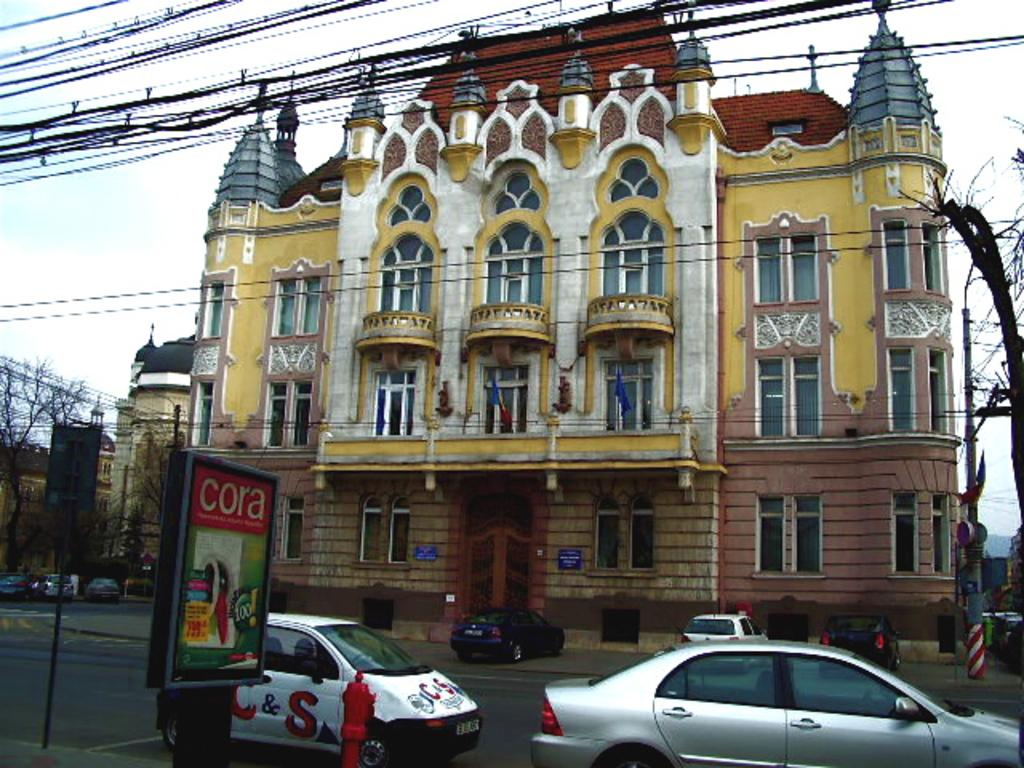What is happening on the road in the image? There are vehicles on the road in the image. What object can be seen on the road in the image? There is a fire hydrant on the road in the image. What can be seen in the background of the image? There are buildings, poles with wires, and name boards in the background of the image. What is visible at the top of the image? The sky is visible at the top of the image. What type of treatment is being administered to the neck in the image? There is no treatment or neck present in the image; it features vehicles on the road, a fire hydrant, buildings, poles with wires, name boards, and the sky. 